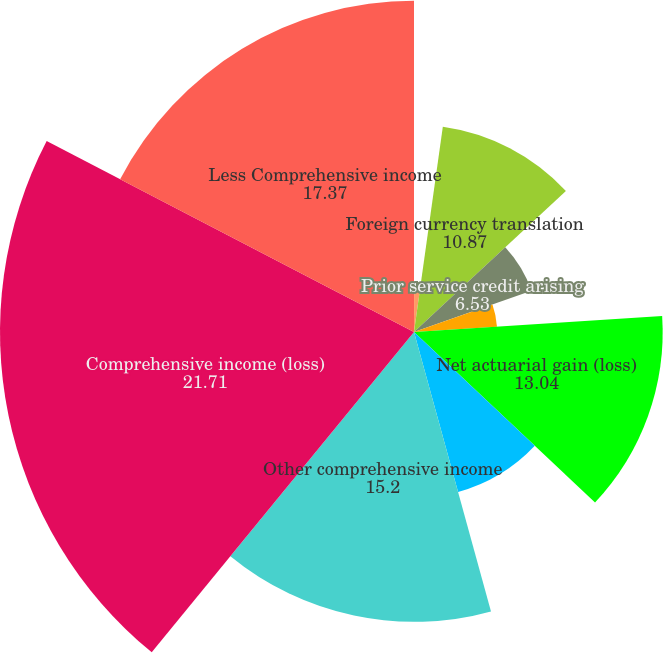<chart> <loc_0><loc_0><loc_500><loc_500><pie_chart><fcel>Cash flow hedging activities<fcel>Reclassifications into<fcel>Foreign currency translation<fcel>Prior service credit arising<fcel>Amortization of prior service<fcel>Net actuarial gain (loss)<fcel>Amortization of actuarial<fcel>Other comprehensive income<fcel>Comprehensive income (loss)<fcel>Less Comprehensive income<nl><fcel>0.03%<fcel>2.19%<fcel>10.87%<fcel>6.53%<fcel>4.36%<fcel>13.04%<fcel>8.7%<fcel>15.2%<fcel>21.71%<fcel>17.37%<nl></chart> 